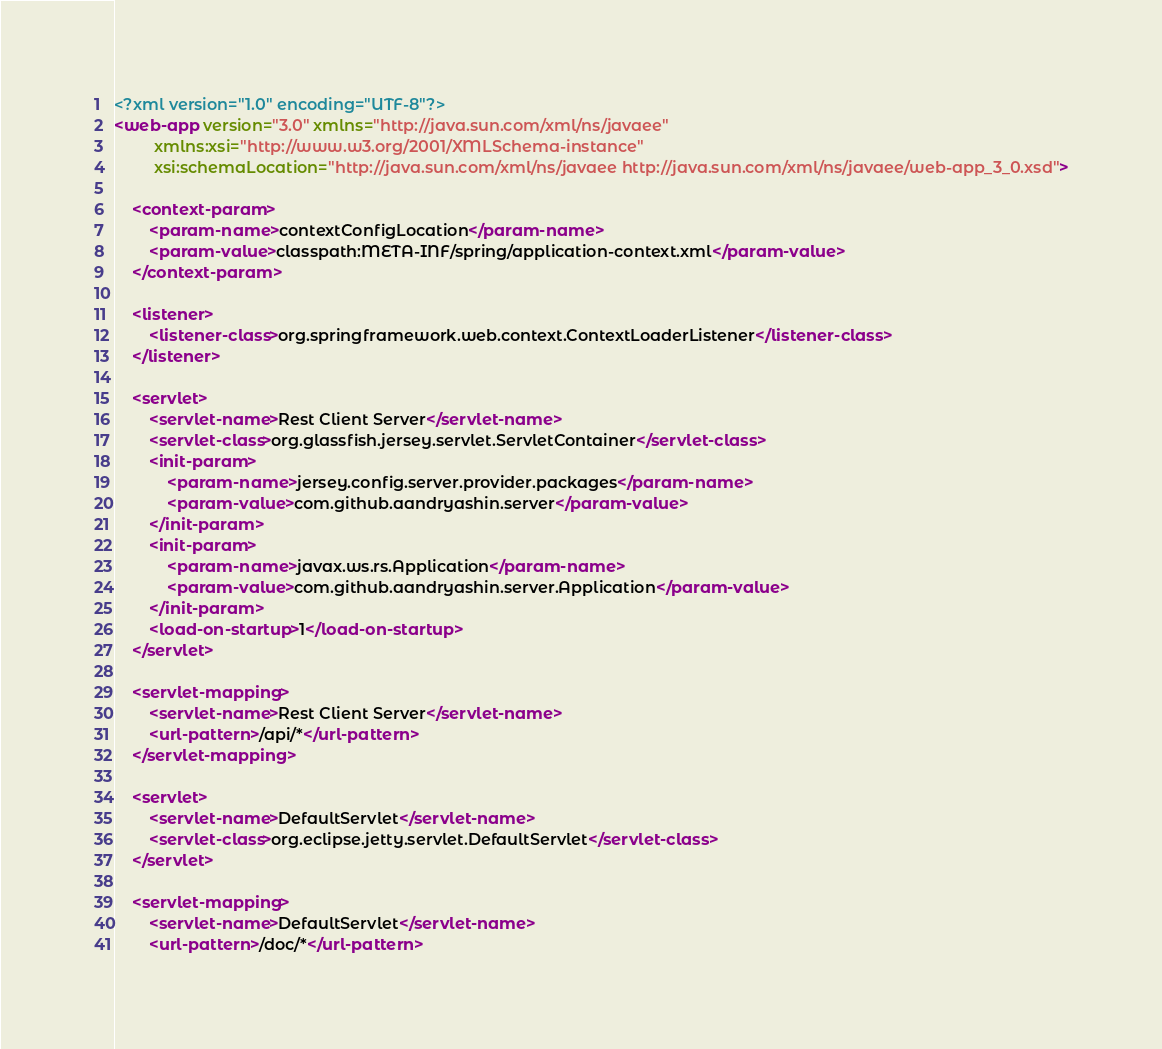Convert code to text. <code><loc_0><loc_0><loc_500><loc_500><_XML_><?xml version="1.0" encoding="UTF-8"?>
<web-app version="3.0" xmlns="http://java.sun.com/xml/ns/javaee"
         xmlns:xsi="http://www.w3.org/2001/XMLSchema-instance"
         xsi:schemaLocation="http://java.sun.com/xml/ns/javaee http://java.sun.com/xml/ns/javaee/web-app_3_0.xsd">

    <context-param>
        <param-name>contextConfigLocation</param-name>
        <param-value>classpath:META-INF/spring/application-context.xml</param-value>
    </context-param>

    <listener>
        <listener-class>org.springframework.web.context.ContextLoaderListener</listener-class>
    </listener>

    <servlet>
        <servlet-name>Rest Client Server</servlet-name>
        <servlet-class>org.glassfish.jersey.servlet.ServletContainer</servlet-class>
        <init-param>
            <param-name>jersey.config.server.provider.packages</param-name>
            <param-value>com.github.aandryashin.server</param-value>
        </init-param>
        <init-param>
            <param-name>javax.ws.rs.Application</param-name>
            <param-value>com.github.aandryashin.server.Application</param-value>
        </init-param>
        <load-on-startup>1</load-on-startup>
    </servlet>

    <servlet-mapping>
        <servlet-name>Rest Client Server</servlet-name>
        <url-pattern>/api/*</url-pattern>
    </servlet-mapping>

    <servlet>
        <servlet-name>DefaultServlet</servlet-name>
        <servlet-class>org.eclipse.jetty.servlet.DefaultServlet</servlet-class>
    </servlet>

    <servlet-mapping>
        <servlet-name>DefaultServlet</servlet-name>
        <url-pattern>/doc/*</url-pattern></code> 